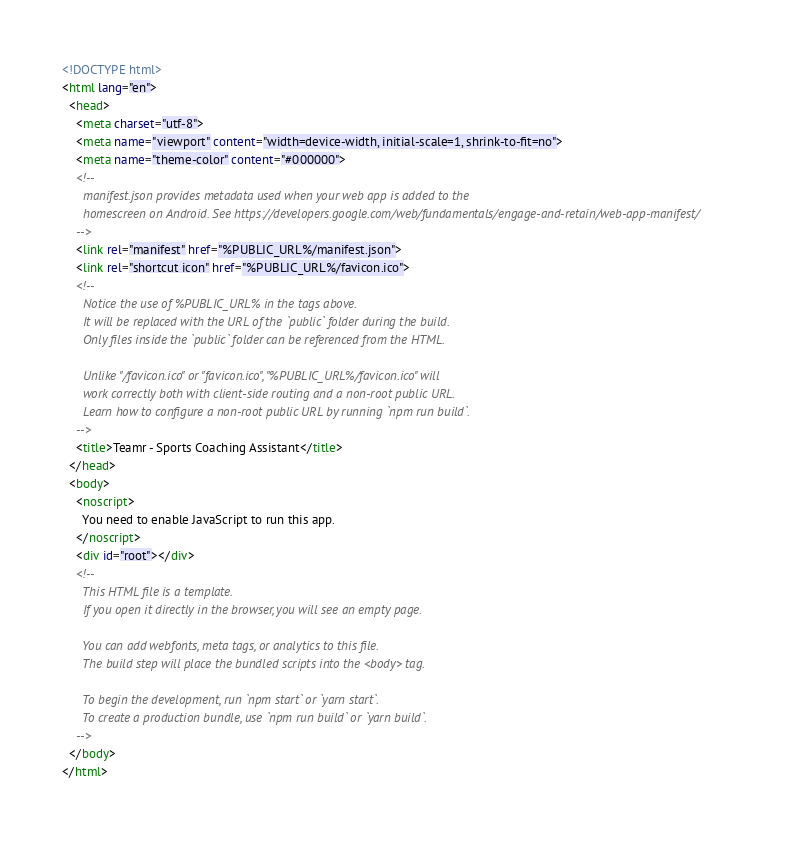<code> <loc_0><loc_0><loc_500><loc_500><_HTML_><!DOCTYPE html>
<html lang="en">
  <head>
    <meta charset="utf-8">
    <meta name="viewport" content="width=device-width, initial-scale=1, shrink-to-fit=no">
    <meta name="theme-color" content="#000000">
    <!--
      manifest.json provides metadata used when your web app is added to the
      homescreen on Android. See https://developers.google.com/web/fundamentals/engage-and-retain/web-app-manifest/
    -->
    <link rel="manifest" href="%PUBLIC_URL%/manifest.json">
    <link rel="shortcut icon" href="%PUBLIC_URL%/favicon.ico">
    <!--
      Notice the use of %PUBLIC_URL% in the tags above.
      It will be replaced with the URL of the `public` folder during the build.
      Only files inside the `public` folder can be referenced from the HTML.

      Unlike "/favicon.ico" or "favicon.ico", "%PUBLIC_URL%/favicon.ico" will
      work correctly both with client-side routing and a non-root public URL.
      Learn how to configure a non-root public URL by running `npm run build`.
    -->
    <title>Teamr - Sports Coaching Assistant</title>
  </head>
  <body>
    <noscript>
      You need to enable JavaScript to run this app.
    </noscript>
    <div id="root"></div>
    <!--
      This HTML file is a template.
      If you open it directly in the browser, you will see an empty page.

      You can add webfonts, meta tags, or analytics to this file.
      The build step will place the bundled scripts into the <body> tag.

      To begin the development, run `npm start` or `yarn start`.
      To create a production bundle, use `npm run build` or `yarn build`.
    -->
  </body>
</html>
</code> 